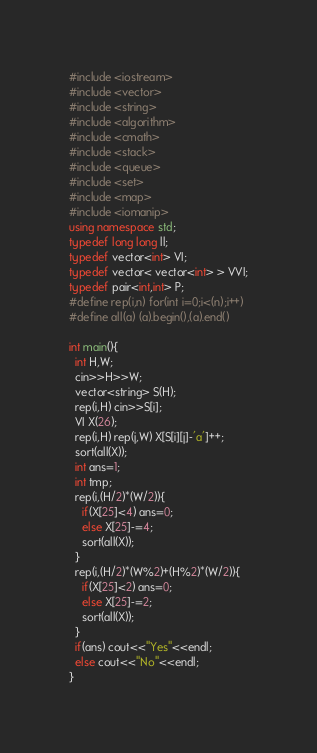Convert code to text. <code><loc_0><loc_0><loc_500><loc_500><_C++_>#include <iostream>
#include <vector>
#include <string>
#include <algorithm>
#include <cmath>
#include <stack>
#include <queue>
#include <set>
#include <map>
#include <iomanip>
using namespace std;
typedef long long ll;
typedef vector<int> VI;
typedef vector< vector<int> > VVI;
typedef pair<int,int> P;
#define rep(i,n) for(int i=0;i<(n);i++)
#define all(a) (a).begin(),(a).end()

int main(){
  int H,W;
  cin>>H>>W;
  vector<string> S(H);
  rep(i,H) cin>>S[i];
  VI X(26);
  rep(i,H) rep(j,W) X[S[i][j]-'a']++;
  sort(all(X));
  int ans=1;
  int tmp;
  rep(i,(H/2)*(W/2)){
    if(X[25]<4) ans=0;
    else X[25]-=4;
    sort(all(X));
  }
  rep(i,(H/2)*(W%2)+(H%2)*(W/2)){
    if(X[25]<2) ans=0;
    else X[25]-=2;
    sort(all(X));
  }
  if(ans) cout<<"Yes"<<endl;
  else cout<<"No"<<endl;
}</code> 